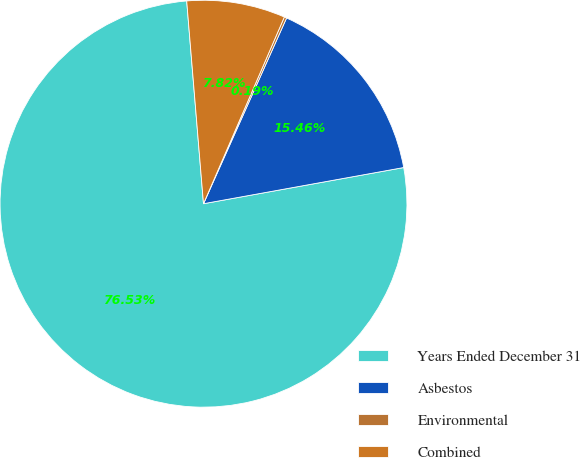<chart> <loc_0><loc_0><loc_500><loc_500><pie_chart><fcel>Years Ended December 31<fcel>Asbestos<fcel>Environmental<fcel>Combined<nl><fcel>76.53%<fcel>15.46%<fcel>0.19%<fcel>7.82%<nl></chart> 